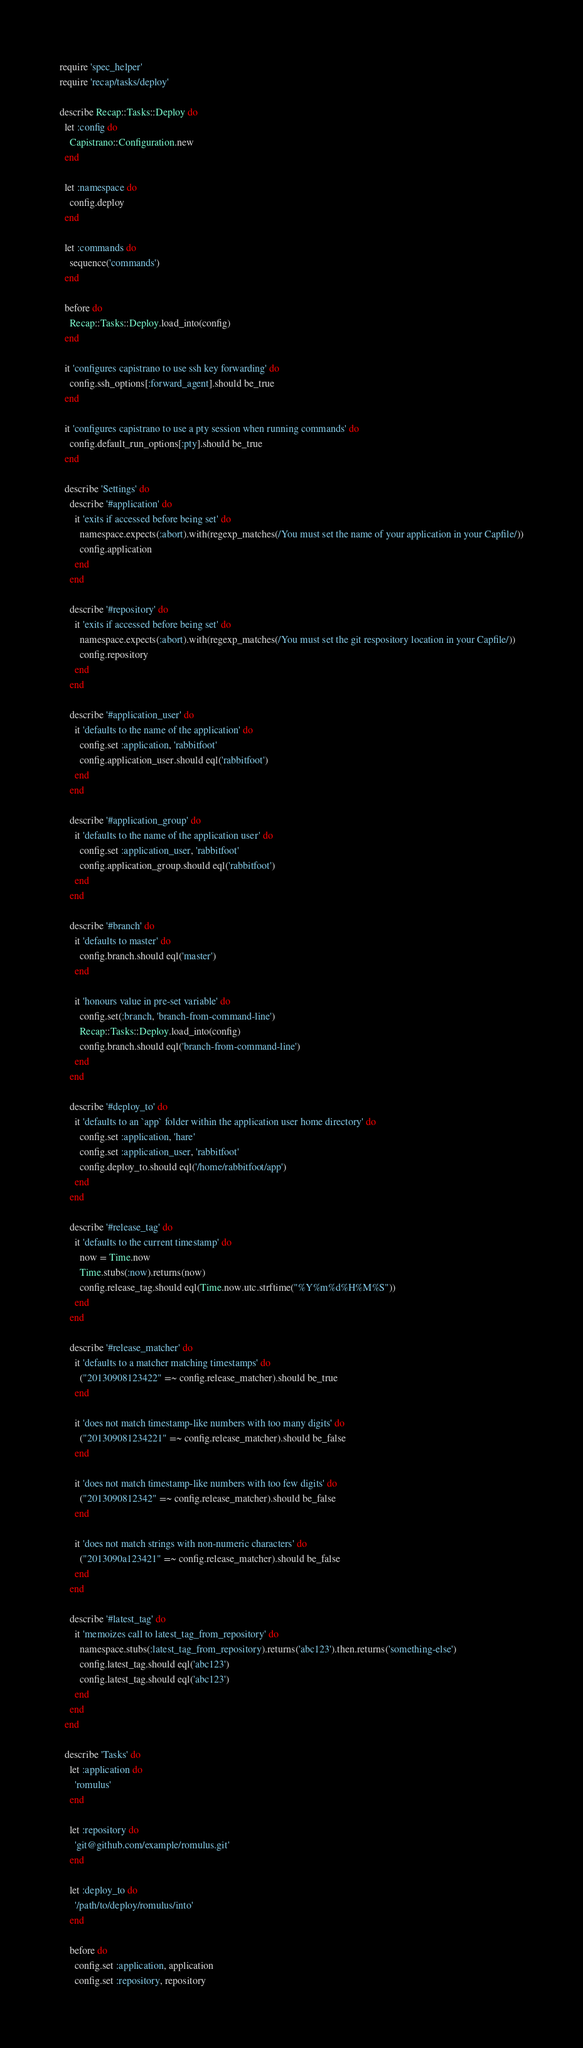<code> <loc_0><loc_0><loc_500><loc_500><_Ruby_>require 'spec_helper'
require 'recap/tasks/deploy'

describe Recap::Tasks::Deploy do
  let :config do
    Capistrano::Configuration.new
  end

  let :namespace do
    config.deploy
  end

  let :commands do
    sequence('commands')
  end

  before do
    Recap::Tasks::Deploy.load_into(config)
  end

  it 'configures capistrano to use ssh key forwarding' do
    config.ssh_options[:forward_agent].should be_true
  end

  it 'configures capistrano to use a pty session when running commands' do
    config.default_run_options[:pty].should be_true
  end

  describe 'Settings' do
    describe '#application' do
      it 'exits if accessed before being set' do
        namespace.expects(:abort).with(regexp_matches(/You must set the name of your application in your Capfile/))
        config.application
      end
    end

    describe '#repository' do
      it 'exits if accessed before being set' do
        namespace.expects(:abort).with(regexp_matches(/You must set the git respository location in your Capfile/))
        config.repository
      end
    end

    describe '#application_user' do
      it 'defaults to the name of the application' do
        config.set :application, 'rabbitfoot'
        config.application_user.should eql('rabbitfoot')
      end
    end

    describe '#application_group' do
      it 'defaults to the name of the application user' do
        config.set :application_user, 'rabbitfoot'
        config.application_group.should eql('rabbitfoot')
      end
    end

    describe '#branch' do
      it 'defaults to master' do
        config.branch.should eql('master')
      end

      it 'honours value in pre-set variable' do
        config.set(:branch, 'branch-from-command-line')
        Recap::Tasks::Deploy.load_into(config)
        config.branch.should eql('branch-from-command-line')
      end
    end

    describe '#deploy_to' do
      it 'defaults to an `app` folder within the application user home directory' do
        config.set :application, 'hare'
        config.set :application_user, 'rabbitfoot'
        config.deploy_to.should eql('/home/rabbitfoot/app')
      end
    end

    describe '#release_tag' do
      it 'defaults to the current timestamp' do
        now = Time.now
        Time.stubs(:now).returns(now)
        config.release_tag.should eql(Time.now.utc.strftime("%Y%m%d%H%M%S"))
      end
    end

    describe '#release_matcher' do
      it 'defaults to a matcher matching timestamps' do
        ("20130908123422" =~ config.release_matcher).should be_true
      end

      it 'does not match timestamp-like numbers with too many digits' do
        ("201309081234221" =~ config.release_matcher).should be_false
      end

      it 'does not match timestamp-like numbers with too few digits' do
        ("2013090812342" =~ config.release_matcher).should be_false
      end

      it 'does not match strings with non-numeric characters' do
        ("2013090a123421" =~ config.release_matcher).should be_false
      end
    end

    describe '#latest_tag' do
      it 'memoizes call to latest_tag_from_repository' do
        namespace.stubs(:latest_tag_from_repository).returns('abc123').then.returns('something-else')
        config.latest_tag.should eql('abc123')
        config.latest_tag.should eql('abc123')
      end
    end
  end

  describe 'Tasks' do
    let :application do
      'romulus'
    end

    let :repository do
      'git@github.com/example/romulus.git'
    end

    let :deploy_to do
      '/path/to/deploy/romulus/into'
    end

    before do
      config.set :application, application
      config.set :repository, repository</code> 